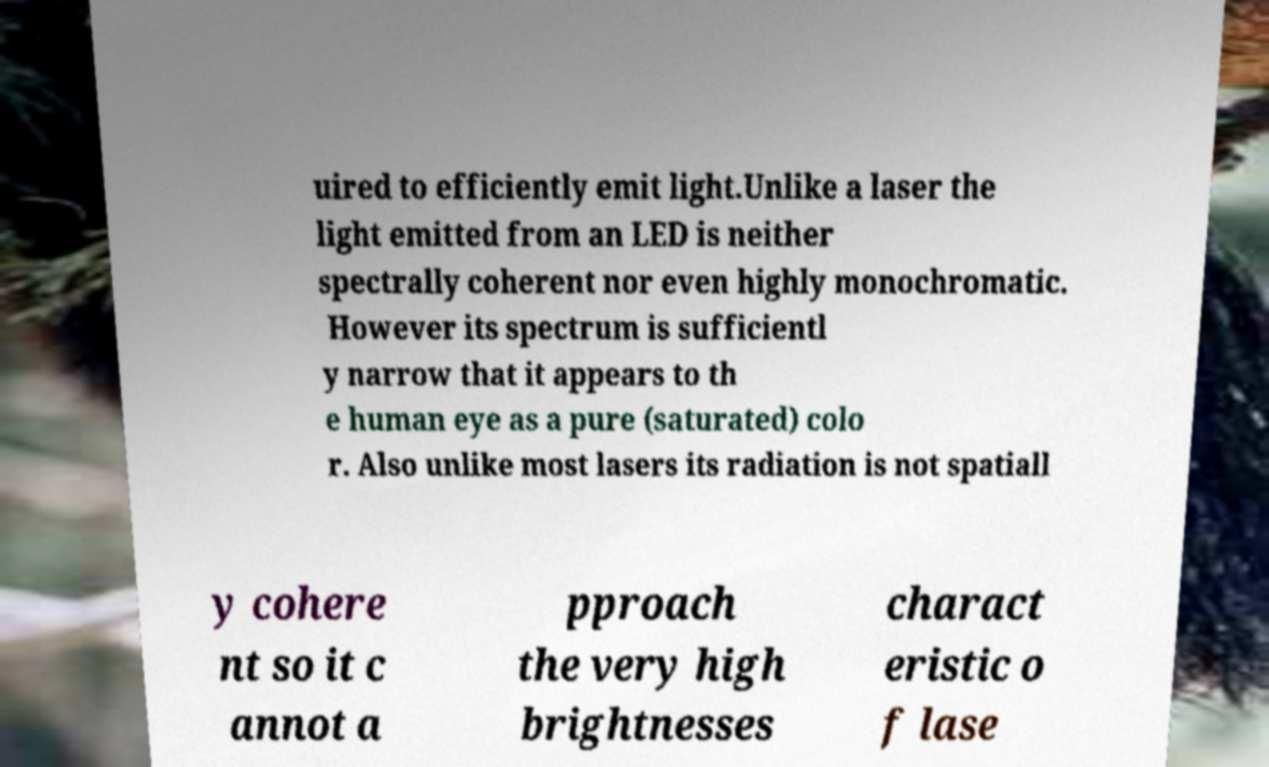There's text embedded in this image that I need extracted. Can you transcribe it verbatim? uired to efficiently emit light.Unlike a laser the light emitted from an LED is neither spectrally coherent nor even highly monochromatic. However its spectrum is sufficientl y narrow that it appears to th e human eye as a pure (saturated) colo r. Also unlike most lasers its radiation is not spatiall y cohere nt so it c annot a pproach the very high brightnesses charact eristic o f lase 